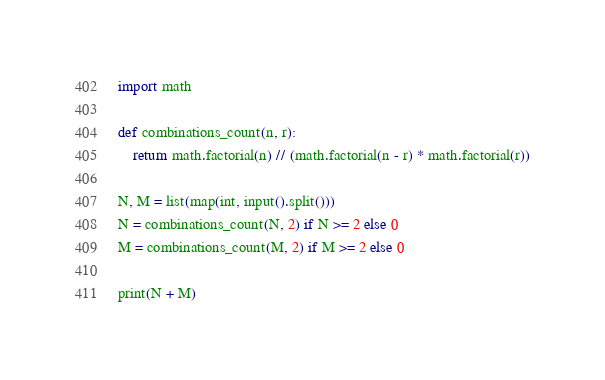<code> <loc_0><loc_0><loc_500><loc_500><_Python_>import math

def combinations_count(n, r):
    return math.factorial(n) // (math.factorial(n - r) * math.factorial(r))

N, M = list(map(int, input().split()))
N = combinations_count(N, 2) if N >= 2 else 0
M = combinations_count(M, 2) if M >= 2 else 0

print(N + M)</code> 